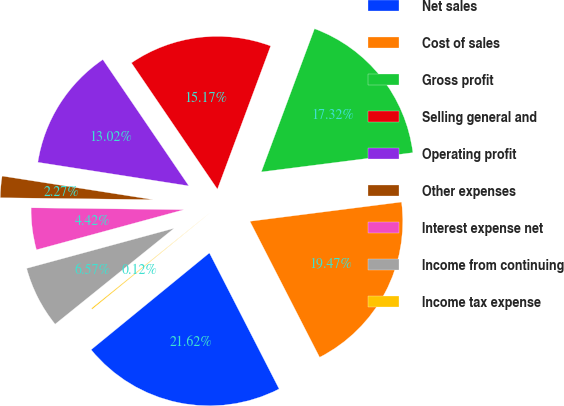<chart> <loc_0><loc_0><loc_500><loc_500><pie_chart><fcel>Net sales<fcel>Cost of sales<fcel>Gross profit<fcel>Selling general and<fcel>Operating profit<fcel>Other expenses<fcel>Interest expense net<fcel>Income from continuing<fcel>Income tax expense<nl><fcel>21.62%<fcel>19.47%<fcel>17.32%<fcel>15.17%<fcel>13.02%<fcel>2.27%<fcel>4.42%<fcel>6.57%<fcel>0.12%<nl></chart> 